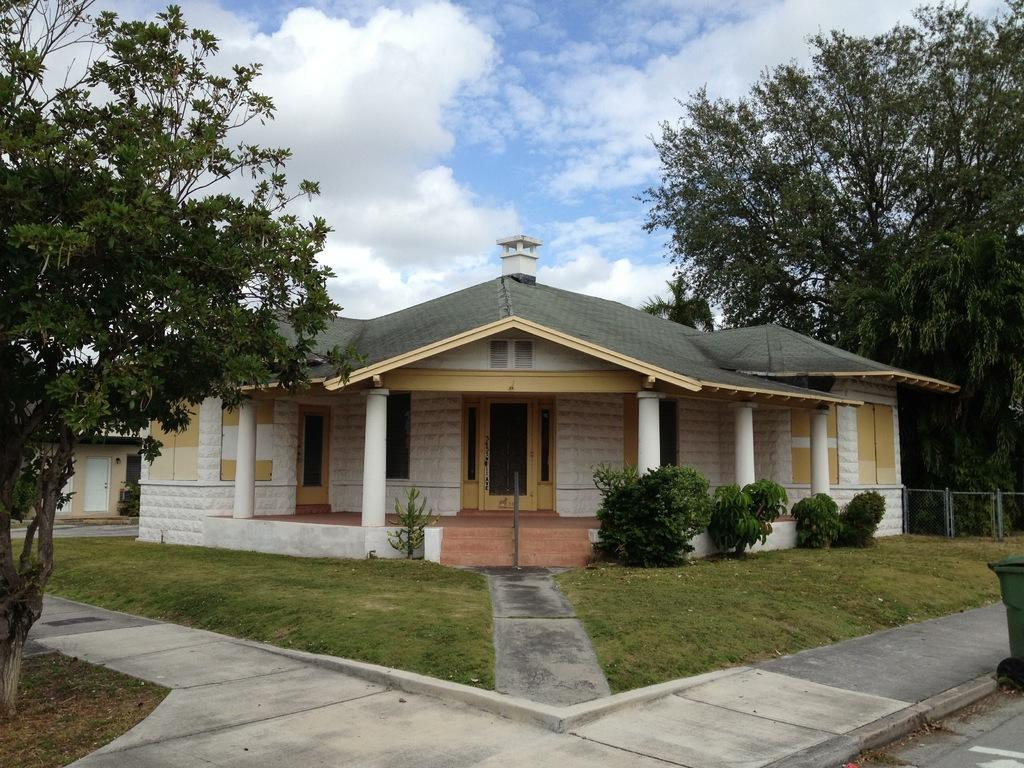What type of structure is visible in the image? There is a house in the image. What is located in front of the house? There is a garden in front of the house. What features can be seen in the garden? There are paths in the garden. How many trees are visible in the image? There is a tree on the left side of the image and another tree in the background of the image. What is visible in the background of the image? The sky is visible in the background of the image. What type of spark can be seen on the hand of the person in the image? There is no person present in the image, and therefore no hand or spark can be observed. 